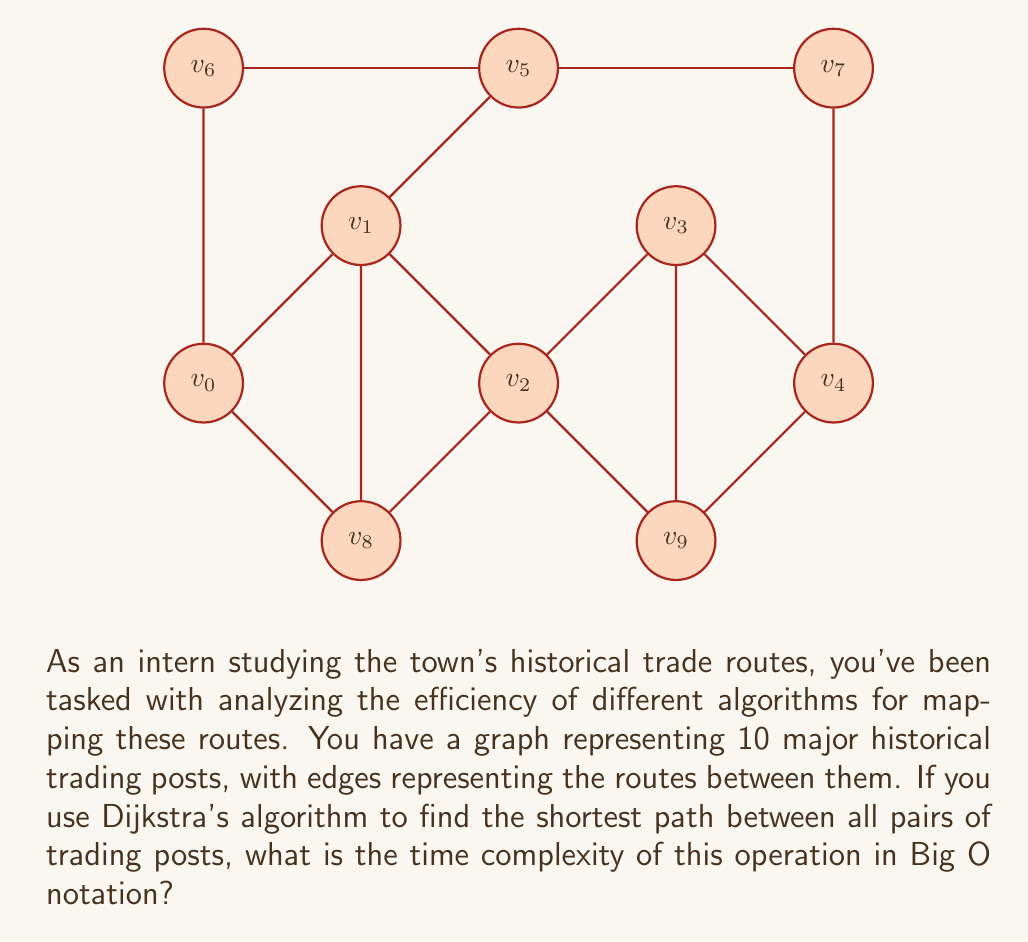What is the answer to this math problem? To solve this problem, let's break it down step-by-step:

1) First, recall that Dijkstra's algorithm finds the shortest path from one node to all other nodes in a weighted graph.

2) The time complexity of Dijkstra's algorithm for a single source node is $O((V + E) \log V)$, where $V$ is the number of vertices and $E$ is the number of edges.

3) In this case, we need to find the shortest path between all pairs of nodes. This means we need to run Dijkstra's algorithm once for each node as the source.

4) We have 10 nodes (trading posts) in our graph. So, we need to run Dijkstra's algorithm 10 times.

5) The time complexity for running Dijkstra's algorithm 10 times is:

   $10 \times O((V + E) \log V) = O(V(V + E) \log V)$

6) In the worst case, a graph with $V$ vertices can have up to $V(V-1)/2$ edges. This means $E$ can be $O(V^2)$.

7) Substituting this into our equation:

   $O(V(V + V^2) \log V) = O(V(V^2) \log V) = O(V^3 \log V)$

8) Therefore, the time complexity of running Dijkstra's algorithm for all pairs of nodes in this graph is $O(V^3 \log V)$.

9) Since we know $V = 10$ in this case, we could write it as $O(1000 \log 10)$, but in Big O notation, we typically express it in terms of $V$.
Answer: $O(V^3 \log V)$ 